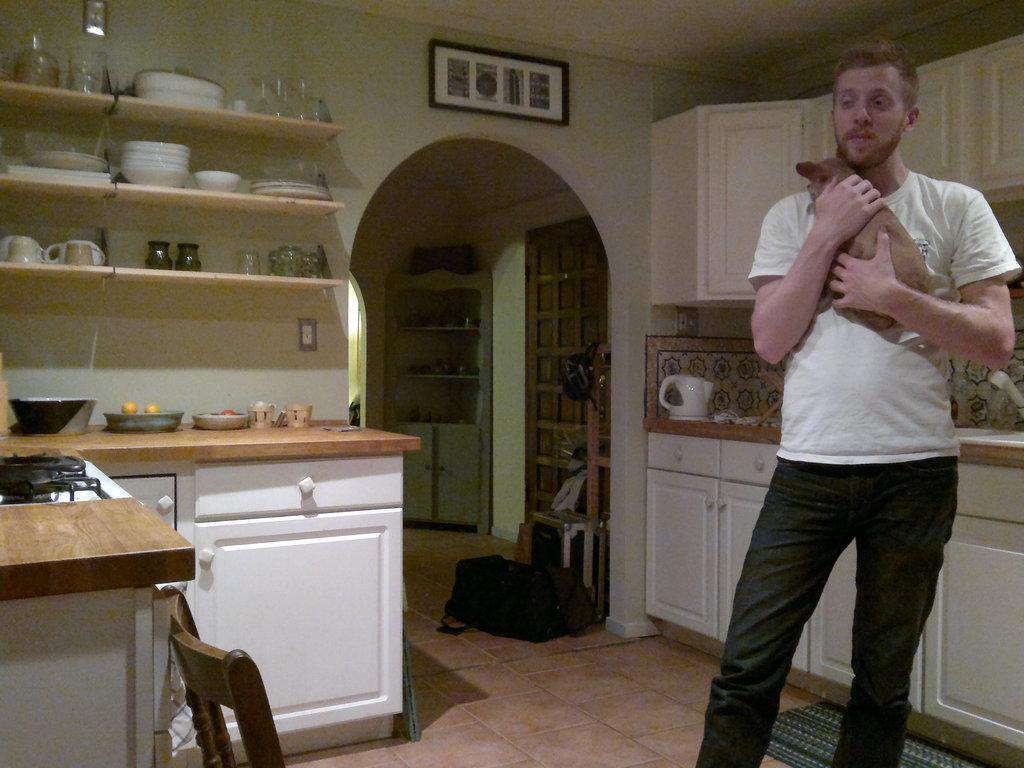Can you describe this image briefly? In this picture we can see a man holding an animal with his hands, standing on the floor, bag, cupboards, kettle, stove, plates, cups, shelves, bowls, shelves, some objects and in the background we can see a frame on the wall, ceiling. 